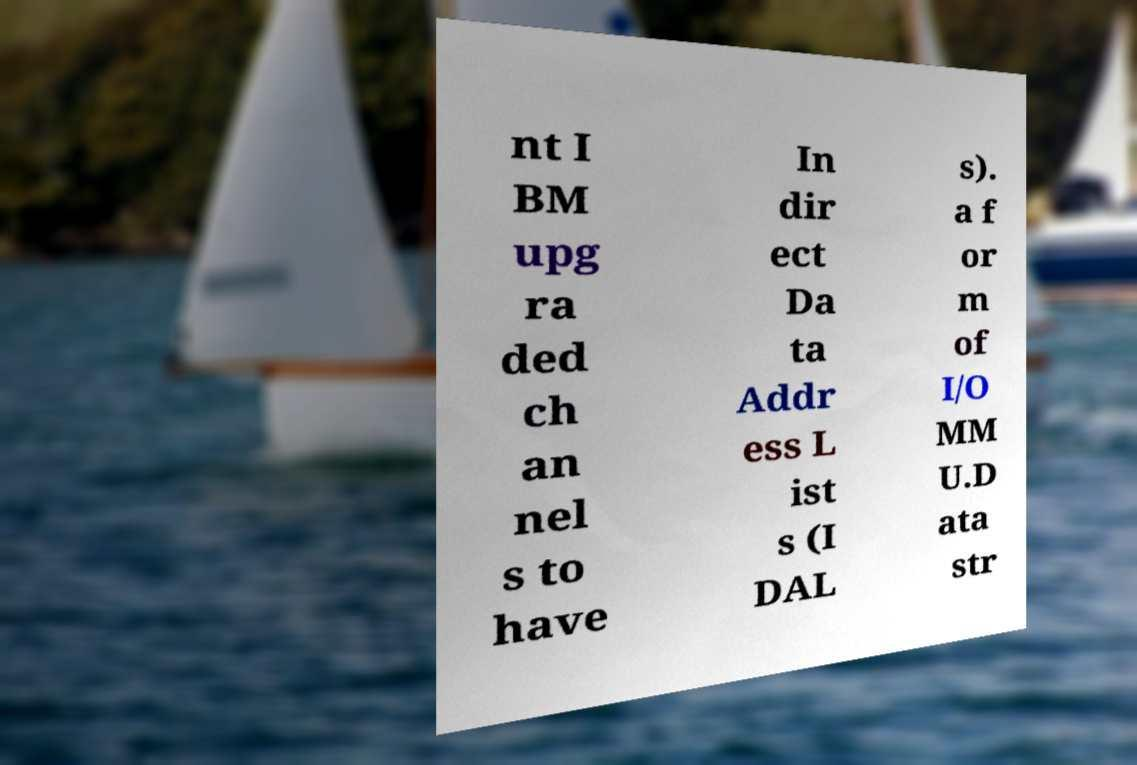Can you read and provide the text displayed in the image?This photo seems to have some interesting text. Can you extract and type it out for me? nt I BM upg ra ded ch an nel s to have In dir ect Da ta Addr ess L ist s (I DAL s). a f or m of I/O MM U.D ata str 